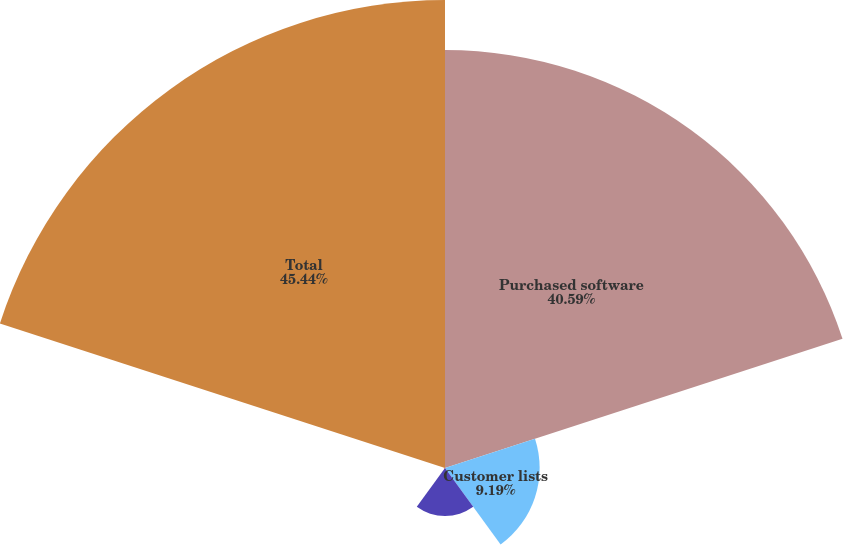Convert chart. <chart><loc_0><loc_0><loc_500><loc_500><pie_chart><fcel>Purchased software<fcel>Customer lists<fcel>Patents<fcel>Non-compete agreements<fcel>Total<nl><fcel>40.59%<fcel>9.19%<fcel>4.66%<fcel>0.12%<fcel>45.45%<nl></chart> 